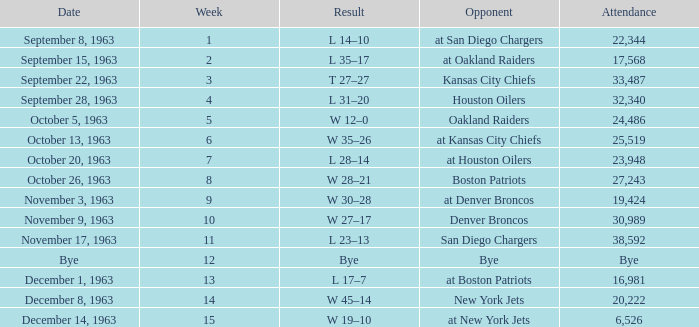Which Opponent has a Date of november 17, 1963? San Diego Chargers. 